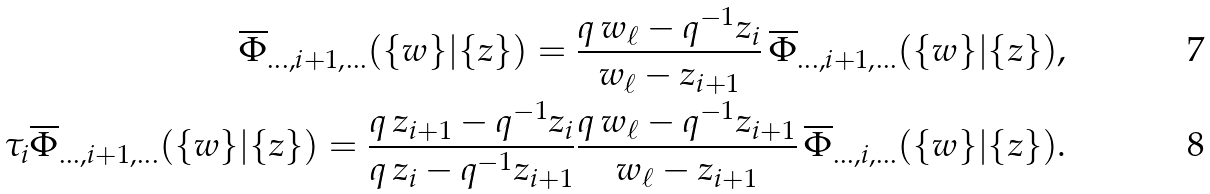Convert formula to latex. <formula><loc_0><loc_0><loc_500><loc_500>\overline { \Phi } _ { \dots , i + 1 , \dots } ( \{ w \} | \{ z \} ) = \frac { q \, w _ { \ell } - q ^ { - 1 } z _ { i } } { w _ { \ell } - z _ { i + 1 } } \, \overline { \Phi } _ { \dots , i + 1 , \dots } ( \{ w \} | \{ z \} ) , \\ \tau _ { i } \overline { \Phi } _ { \dots , i + 1 , \dots } ( \{ w \} | \{ z \} ) = \frac { q \, z _ { i + 1 } - q ^ { - 1 } z _ { i } } { q \, z _ { i } - q ^ { - 1 } z _ { i + 1 } } \frac { q \, w _ { \ell } - q ^ { - 1 } z _ { i + 1 } } { w _ { \ell } - z _ { i + 1 } } \, \overline { \Phi } _ { \dots , i , \dots } ( \{ w \} | \{ z \} ) .</formula> 